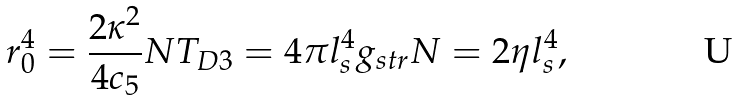Convert formula to latex. <formula><loc_0><loc_0><loc_500><loc_500>r _ { 0 } ^ { 4 } = \frac { 2 \kappa ^ { 2 } } { 4 c _ { 5 } } N T _ { D 3 } = 4 \pi l _ { s } ^ { 4 } g _ { s t r } N = 2 \eta l _ { s } ^ { 4 } ,</formula> 